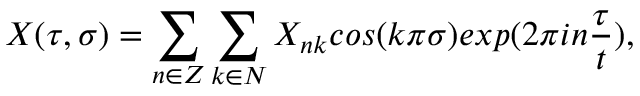Convert formula to latex. <formula><loc_0><loc_0><loc_500><loc_500>X ( \tau , \sigma ) = \sum _ { n \in Z } \sum _ { k \in N } X _ { n k } \cos ( k \pi \sigma ) e x p ( 2 \pi i n \frac { \tau } { t } ) ,</formula> 